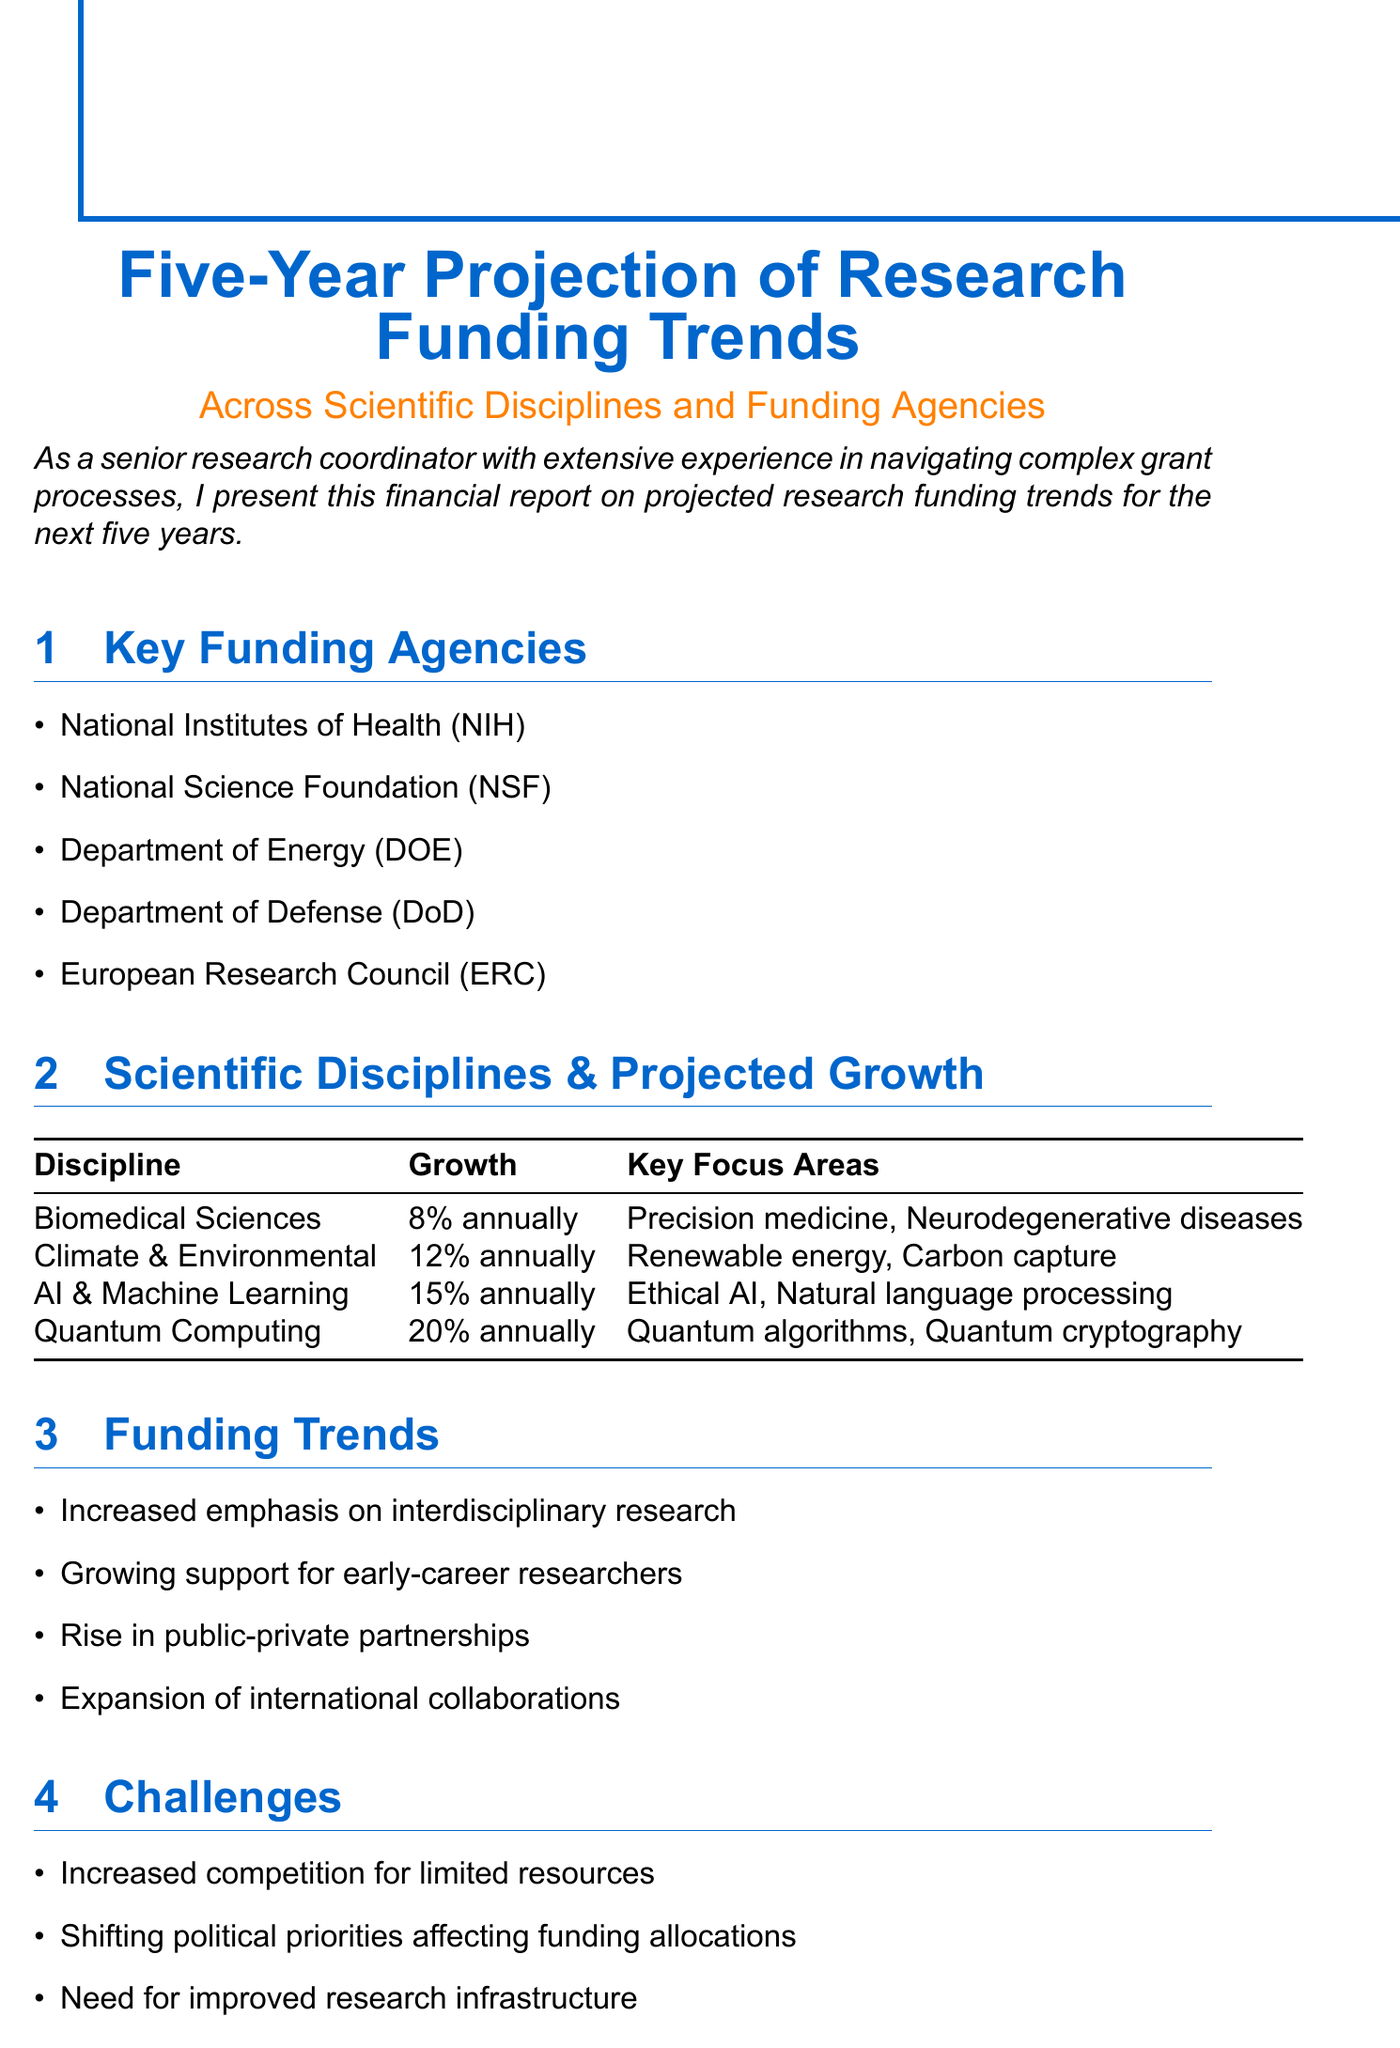What is the projected growth for Biomedical Sciences? The projected growth for Biomedical Sciences is specified in the document as 8% annually.
Answer: 8% annually Which funding agency's acronym is NIH? The document lists the National Institutes of Health as the organization represented by the acronym NIH.
Answer: National Institutes of Health What are two key focus areas of Climate and Environmental Sciences? The document mentions Renewable energy and Carbon capture as key focus areas for Climate and Environmental Sciences.
Answer: Renewable energy, Carbon capture What challenge is mentioned regarding research funding? The document identifies increased competition for limited resources as a challenge facing research funding.
Answer: Increased competition for limited resources What recommendation is made related to grant management? The document suggests investing in grant writing and management training as a recommendation.
Answer: Invest in grant writing and management training What is the projected growth for Quantum Computing? According to the financial report, Quantum Computing is projected to grow 20% annually.
Answer: 20% annually Which scientific discipline has the highest projected growth? The document states that Quantum Computing has the highest projected growth at 20% annually.
Answer: Quantum Computing What funding trend emphasizes the support for early-career researchers? The document discusses the growing support for early-career researchers as a funding trend.
Answer: Growing support for early-career researchers 